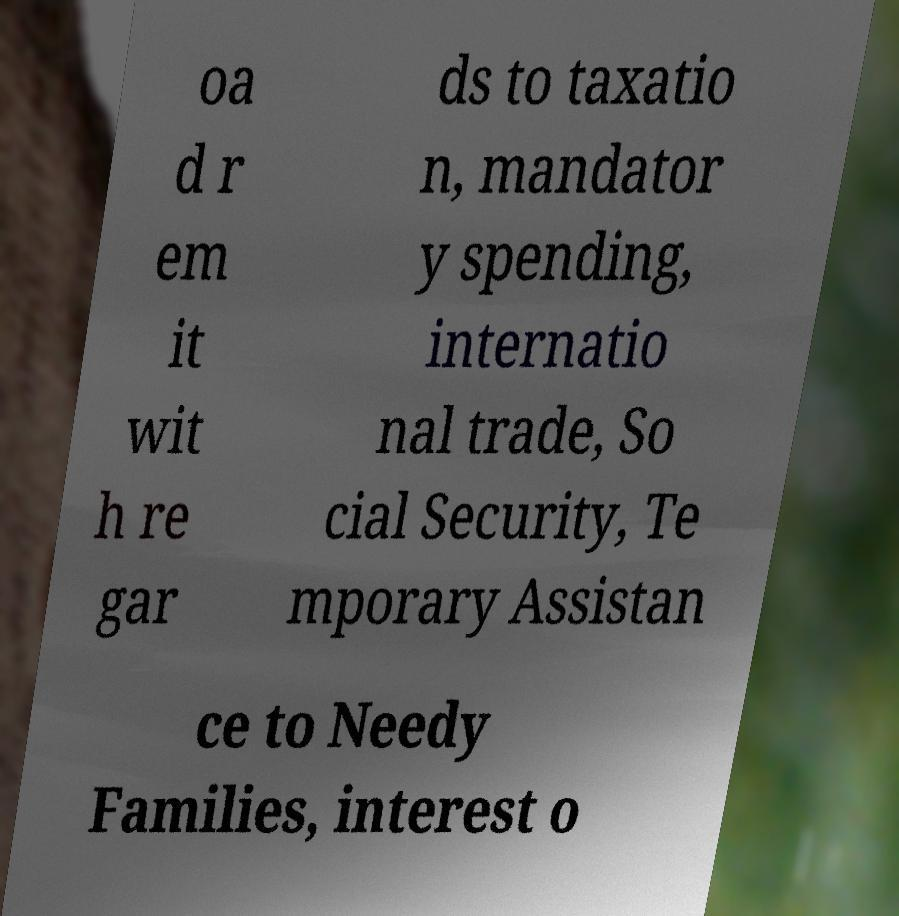I need the written content from this picture converted into text. Can you do that? oa d r em it wit h re gar ds to taxatio n, mandator y spending, internatio nal trade, So cial Security, Te mporary Assistan ce to Needy Families, interest o 